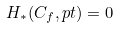Convert formula to latex. <formula><loc_0><loc_0><loc_500><loc_500>H _ { * } ( C _ { f } , p t ) = 0</formula> 